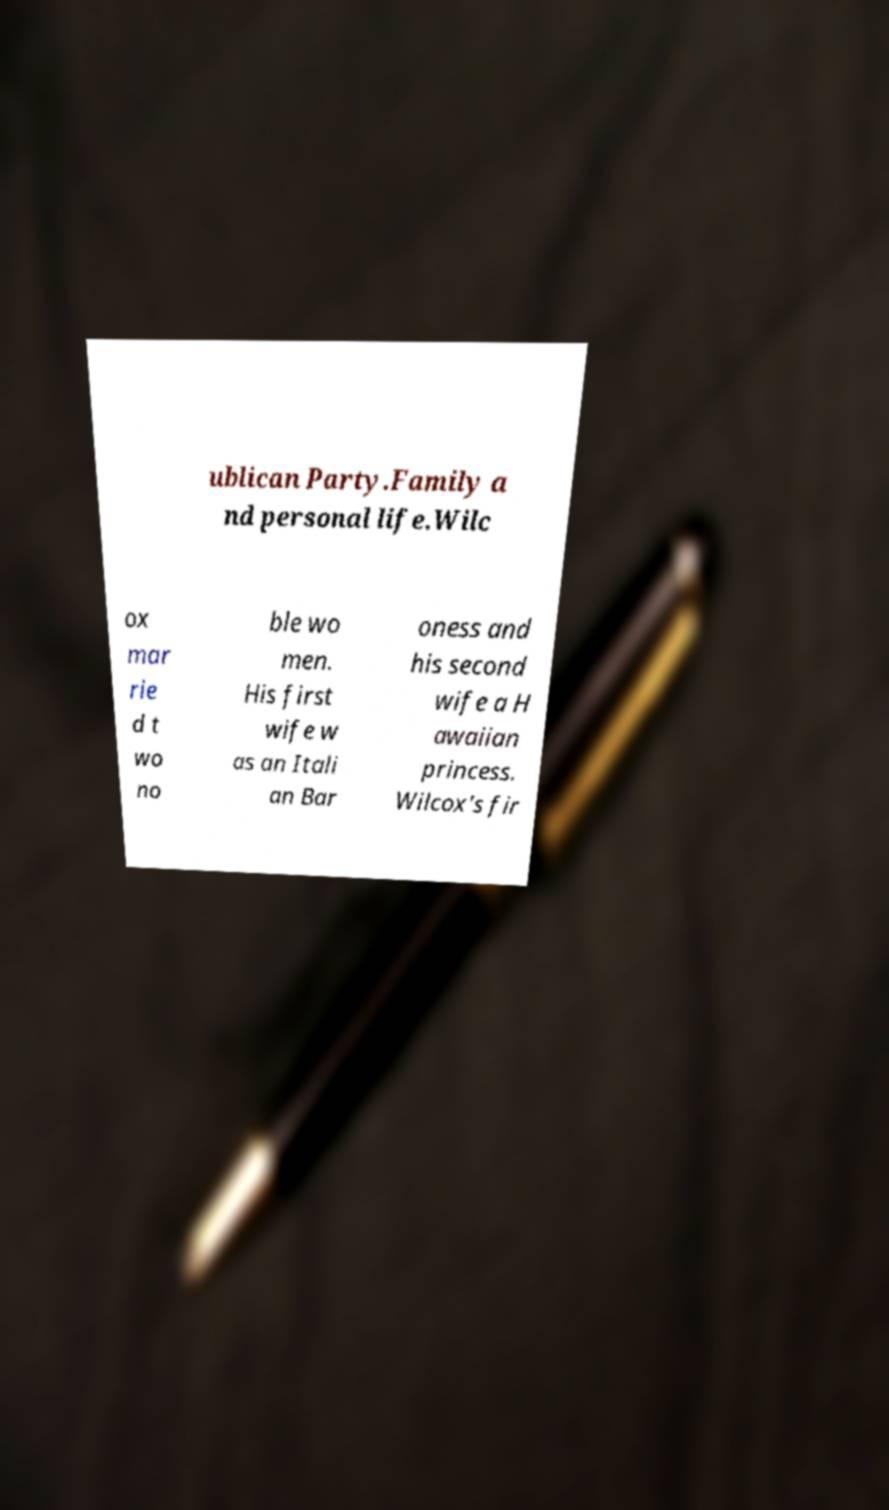What messages or text are displayed in this image? I need them in a readable, typed format. ublican Party.Family a nd personal life.Wilc ox mar rie d t wo no ble wo men. His first wife w as an Itali an Bar oness and his second wife a H awaiian princess. Wilcox's fir 